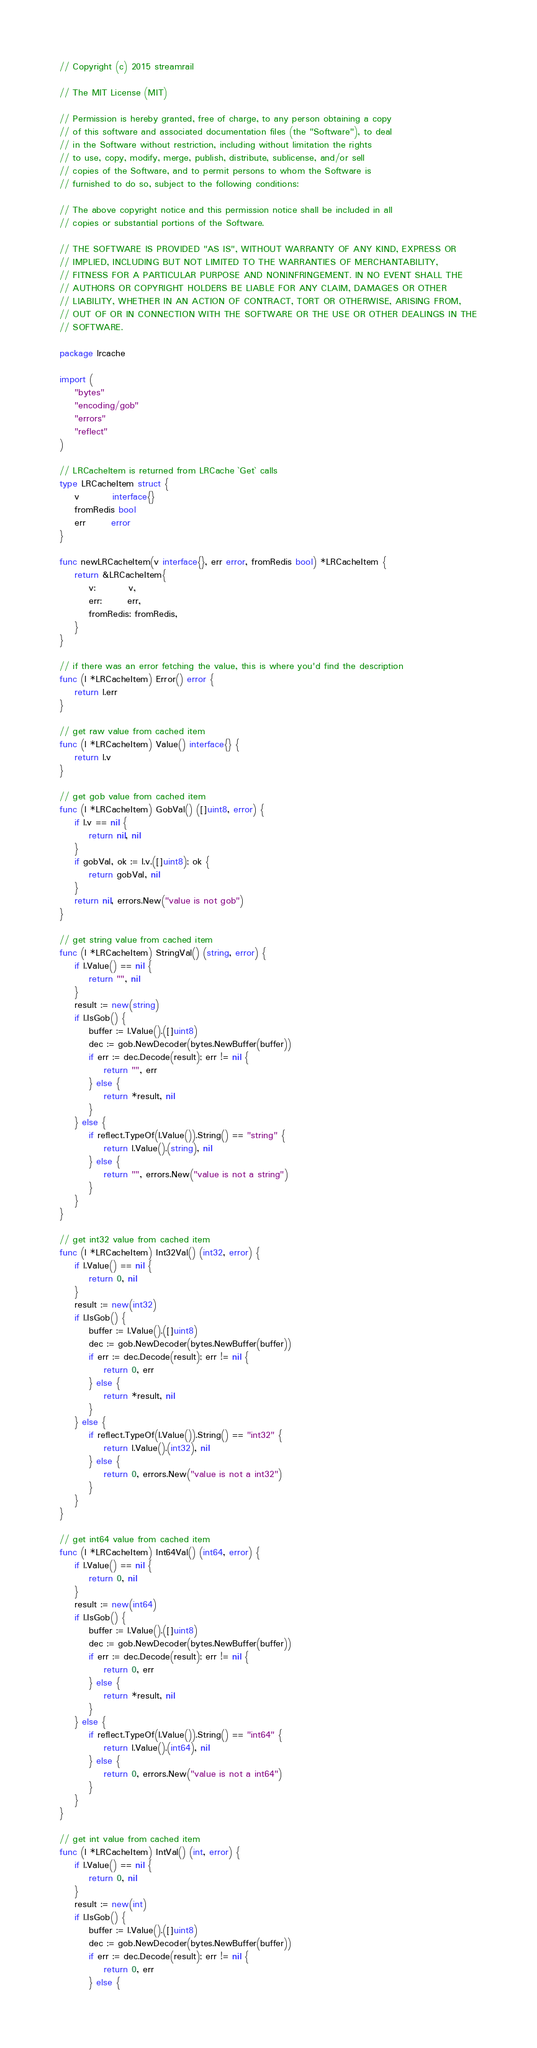Convert code to text. <code><loc_0><loc_0><loc_500><loc_500><_Go_>// Copyright (c) 2015 streamrail

// The MIT License (MIT)

// Permission is hereby granted, free of charge, to any person obtaining a copy
// of this software and associated documentation files (the "Software"), to deal
// in the Software without restriction, including without limitation the rights
// to use, copy, modify, merge, publish, distribute, sublicense, and/or sell
// copies of the Software, and to permit persons to whom the Software is
// furnished to do so, subject to the following conditions:

// The above copyright notice and this permission notice shall be included in all
// copies or substantial portions of the Software.

// THE SOFTWARE IS PROVIDED "AS IS", WITHOUT WARRANTY OF ANY KIND, EXPRESS OR
// IMPLIED, INCLUDING BUT NOT LIMITED TO THE WARRANTIES OF MERCHANTABILITY,
// FITNESS FOR A PARTICULAR PURPOSE AND NONINFRINGEMENT. IN NO EVENT SHALL THE
// AUTHORS OR COPYRIGHT HOLDERS BE LIABLE FOR ANY CLAIM, DAMAGES OR OTHER
// LIABILITY, WHETHER IN AN ACTION OF CONTRACT, TORT OR OTHERWISE, ARISING FROM,
// OUT OF OR IN CONNECTION WITH THE SOFTWARE OR THE USE OR OTHER DEALINGS IN THE
// SOFTWARE.

package lrcache

import (
	"bytes"
	"encoding/gob"
	"errors"
	"reflect"
)

// LRCacheItem is returned from LRCache `Get` calls
type LRCacheItem struct {
	v         interface{}
	fromRedis bool
	err       error
}

func newLRCacheItem(v interface{}, err error, fromRedis bool) *LRCacheItem {
	return &LRCacheItem{
		v:         v,
		err:       err,
		fromRedis: fromRedis,
	}
}

// if there was an error fetching the value, this is where you'd find the description
func (l *LRCacheItem) Error() error {
	return l.err
}

// get raw value from cached item
func (l *LRCacheItem) Value() interface{} {
	return l.v
}

// get gob value from cached item
func (l *LRCacheItem) GobVal() ([]uint8, error) {
	if l.v == nil {
		return nil, nil
	}
	if gobVal, ok := l.v.([]uint8); ok {
		return gobVal, nil
	}
	return nil, errors.New("value is not gob")
}

// get string value from cached item
func (l *LRCacheItem) StringVal() (string, error) {
	if l.Value() == nil {
		return "", nil
	}
	result := new(string)
	if l.IsGob() {
		buffer := l.Value().([]uint8)
		dec := gob.NewDecoder(bytes.NewBuffer(buffer))
		if err := dec.Decode(result); err != nil {
			return "", err
		} else {
			return *result, nil
		}
	} else {
		if reflect.TypeOf(l.Value()).String() == "string" {
			return l.Value().(string), nil
		} else {
			return "", errors.New("value is not a string")
		}
	}
}

// get int32 value from cached item
func (l *LRCacheItem) Int32Val() (int32, error) {
	if l.Value() == nil {
		return 0, nil
	}
	result := new(int32)
	if l.IsGob() {
		buffer := l.Value().([]uint8)
		dec := gob.NewDecoder(bytes.NewBuffer(buffer))
		if err := dec.Decode(result); err != nil {
			return 0, err
		} else {
			return *result, nil
		}
	} else {
		if reflect.TypeOf(l.Value()).String() == "int32" {
			return l.Value().(int32), nil
		} else {
			return 0, errors.New("value is not a int32")
		}
	}
}

// get int64 value from cached item
func (l *LRCacheItem) Int64Val() (int64, error) {
	if l.Value() == nil {
		return 0, nil
	}
	result := new(int64)
	if l.IsGob() {
		buffer := l.Value().([]uint8)
		dec := gob.NewDecoder(bytes.NewBuffer(buffer))
		if err := dec.Decode(result); err != nil {
			return 0, err
		} else {
			return *result, nil
		}
	} else {
		if reflect.TypeOf(l.Value()).String() == "int64" {
			return l.Value().(int64), nil
		} else {
			return 0, errors.New("value is not a int64")
		}
	}
}

// get int value from cached item
func (l *LRCacheItem) IntVal() (int, error) {
	if l.Value() == nil {
		return 0, nil
	}
	result := new(int)
	if l.IsGob() {
		buffer := l.Value().([]uint8)
		dec := gob.NewDecoder(bytes.NewBuffer(buffer))
		if err := dec.Decode(result); err != nil {
			return 0, err
		} else {</code> 